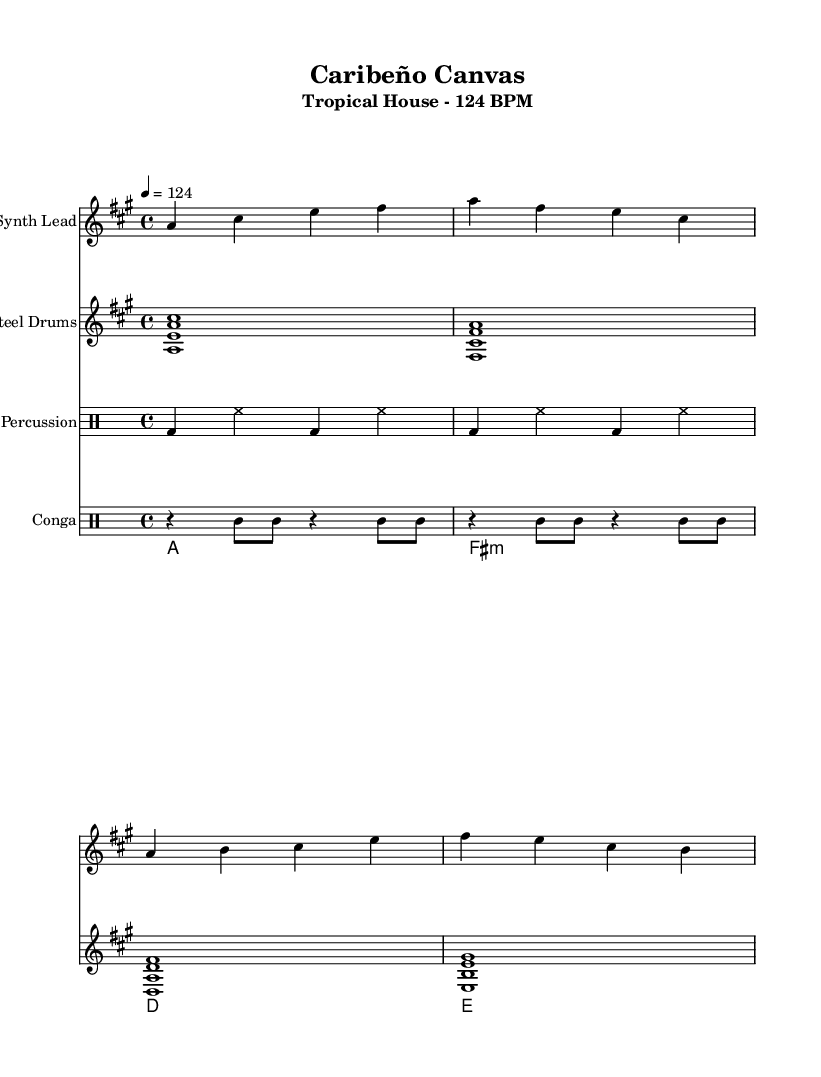What is the key signature of this music? The key signature shown in the sheet music is A major, which includes three sharps: F#, C#, and G#. This can be identified from the key signature indication at the beginning of the score.
Answer: A major What is the time signature of this piece? The time signature displayed in the sheet music is 4/4, which means there are four beats in a measure and the quarter note gets the beat. This can be found at the start of the score where the time signature is indicated.
Answer: 4/4 What is the tempo of this composition? The tempo marking is at 124 beats per minute, which is indicated above the staff. This speed gives a lively feel typical of house music.
Answer: 124 How many measures are in the synth lead part? The synth lead part consists of four measures, which can be counted by looking at the grouping of the notes and their respective bar lines within the staff.
Answer: 4 Which percussion instruments are included in the piece? The percussion instruments used in this piece are electronic percussion and conga. This can be inferred from the distinct drum staff titles listed in the score.
Answer: Electronic percussion and conga What musical element gives a tropical feel to the arrangement? The presence of steel drums provides a tropical feel to the arrangement, as evidenced by its unique sound and specific notation in the score.
Answer: Steel drums What type of rhythm pattern does the electronic percussion use? The electronic percussion employs a bass drum and hi-hat pattern alternating throughout each measure, which is characteristic of house music. This can be determined by analyzing the drummode notation in the electronic percussion section.
Answer: Bass drum and hi-hat 